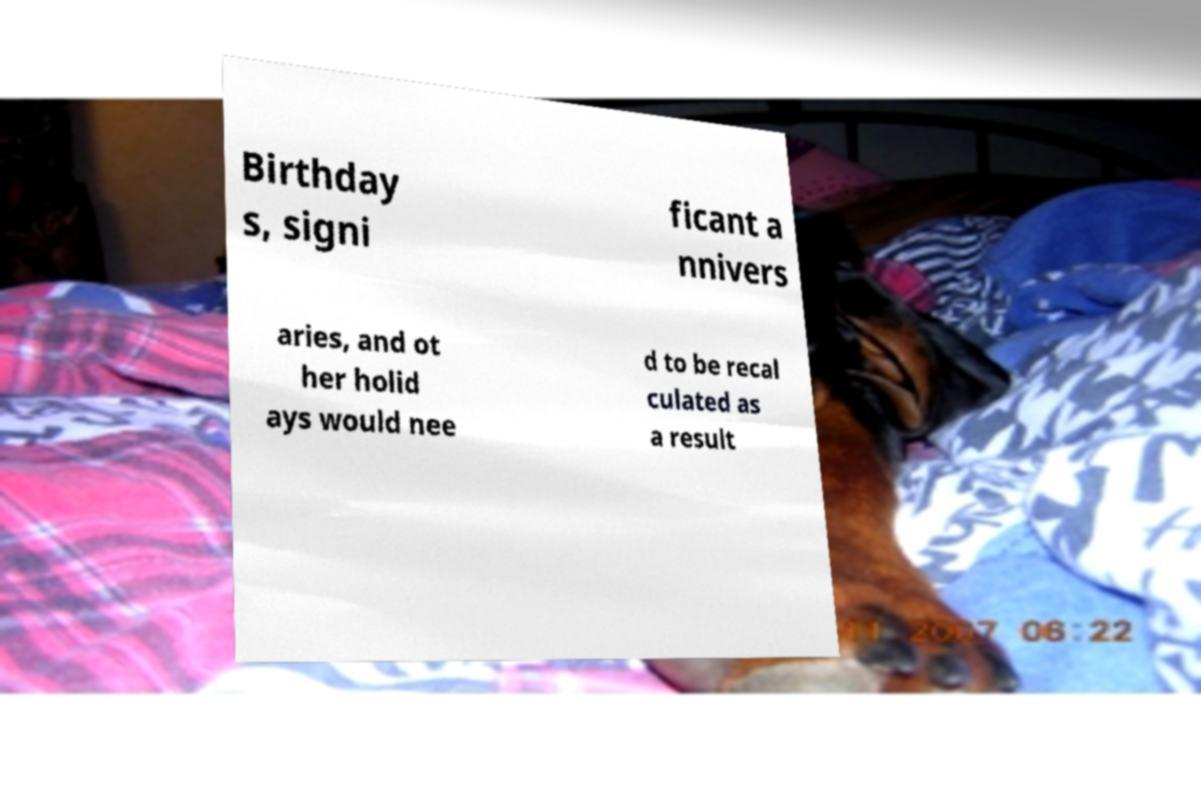What messages or text are displayed in this image? I need them in a readable, typed format. Birthday s, signi ficant a nnivers aries, and ot her holid ays would nee d to be recal culated as a result 